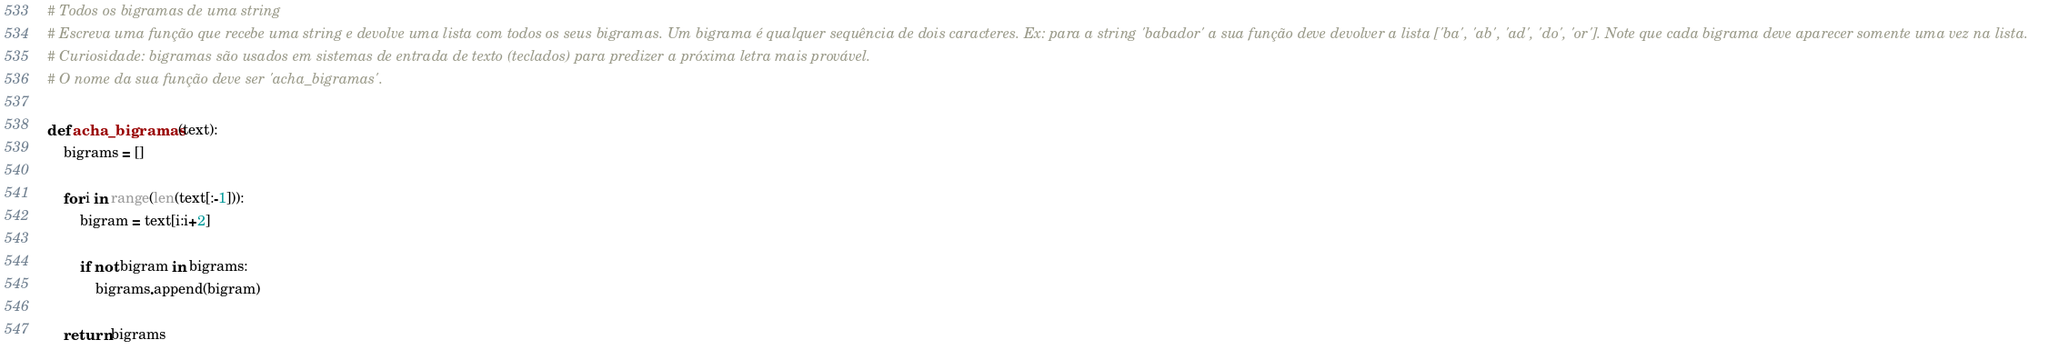<code> <loc_0><loc_0><loc_500><loc_500><_Python_># Todos os bigramas de uma string
# Escreva uma função que recebe uma string e devolve uma lista com todos os seus bigramas. Um bigrama é qualquer sequência de dois caracteres. Ex: para a string 'babador' a sua função deve devolver a lista ['ba', 'ab', 'ad', 'do', 'or']. Note que cada bigrama deve aparecer somente uma vez na lista.
# Curiosidade: bigramas são usados em sistemas de entrada de texto (teclados) para predizer a próxima letra mais provável.
# O nome da sua função deve ser 'acha_bigramas'.

def acha_bigramas (text):
    bigrams = []
    
    for i in range(len(text[:-1])):
        bigram = text[i:i+2]
        
        if not bigram in bigrams:
            bigrams.append(bigram)
        
    return bigrams
</code> 